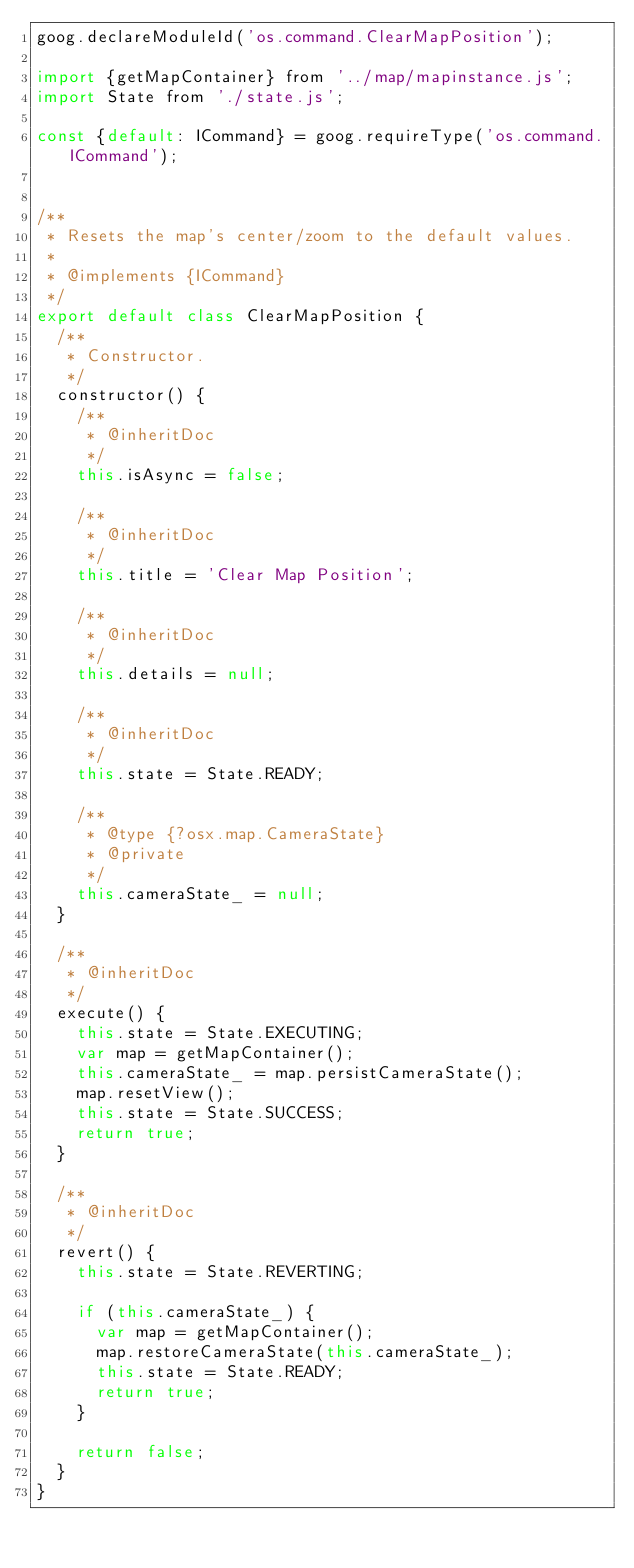Convert code to text. <code><loc_0><loc_0><loc_500><loc_500><_JavaScript_>goog.declareModuleId('os.command.ClearMapPosition');

import {getMapContainer} from '../map/mapinstance.js';
import State from './state.js';

const {default: ICommand} = goog.requireType('os.command.ICommand');


/**
 * Resets the map's center/zoom to the default values.
 *
 * @implements {ICommand}
 */
export default class ClearMapPosition {
  /**
   * Constructor.
   */
  constructor() {
    /**
     * @inheritDoc
     */
    this.isAsync = false;

    /**
     * @inheritDoc
     */
    this.title = 'Clear Map Position';

    /**
     * @inheritDoc
     */
    this.details = null;

    /**
     * @inheritDoc
     */
    this.state = State.READY;

    /**
     * @type {?osx.map.CameraState}
     * @private
     */
    this.cameraState_ = null;
  }

  /**
   * @inheritDoc
   */
  execute() {
    this.state = State.EXECUTING;
    var map = getMapContainer();
    this.cameraState_ = map.persistCameraState();
    map.resetView();
    this.state = State.SUCCESS;
    return true;
  }

  /**
   * @inheritDoc
   */
  revert() {
    this.state = State.REVERTING;

    if (this.cameraState_) {
      var map = getMapContainer();
      map.restoreCameraState(this.cameraState_);
      this.state = State.READY;
      return true;
    }

    return false;
  }
}
</code> 